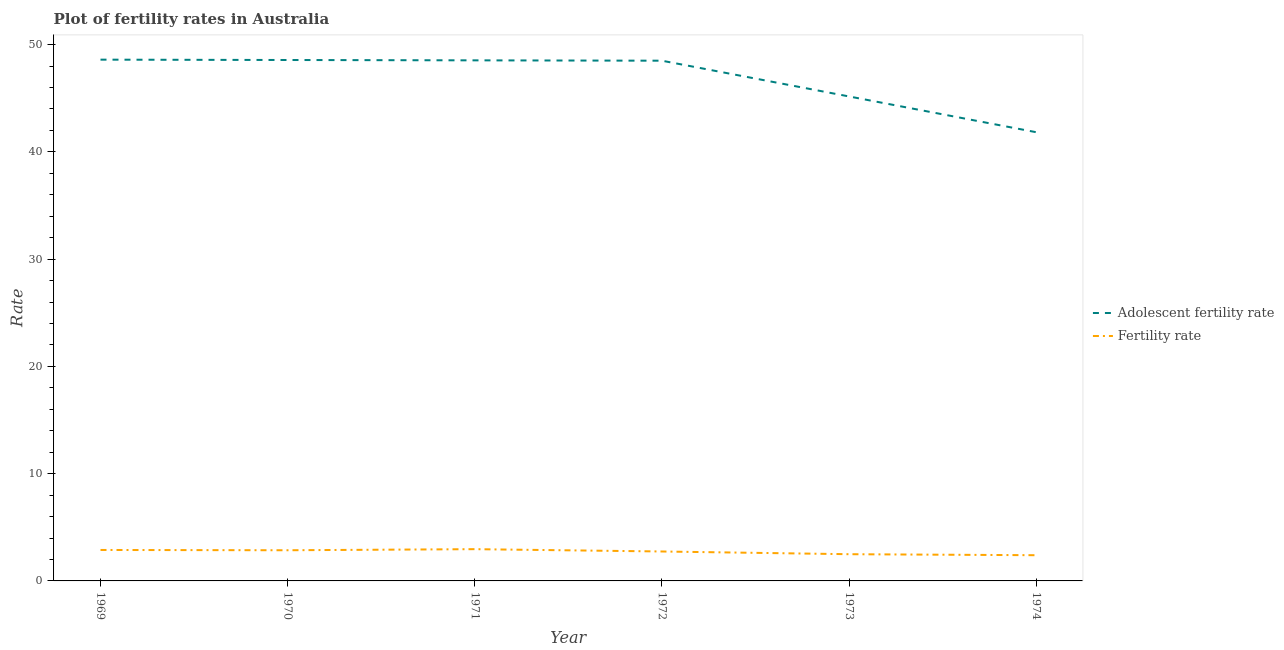How many different coloured lines are there?
Make the answer very short. 2. Does the line corresponding to adolescent fertility rate intersect with the line corresponding to fertility rate?
Provide a succinct answer. No. Is the number of lines equal to the number of legend labels?
Your answer should be very brief. Yes. What is the fertility rate in 1971?
Your answer should be very brief. 2.96. Across all years, what is the maximum adolescent fertility rate?
Your answer should be compact. 48.6. Across all years, what is the minimum adolescent fertility rate?
Your answer should be very brief. 41.83. In which year was the adolescent fertility rate maximum?
Ensure brevity in your answer.  1969. In which year was the adolescent fertility rate minimum?
Your answer should be very brief. 1974. What is the total adolescent fertility rate in the graph?
Offer a very short reply. 281.2. What is the difference between the adolescent fertility rate in 1970 and that in 1972?
Your response must be concise. 0.06. What is the difference between the fertility rate in 1969 and the adolescent fertility rate in 1973?
Give a very brief answer. -42.28. What is the average fertility rate per year?
Your answer should be compact. 2.72. In the year 1969, what is the difference between the adolescent fertility rate and fertility rate?
Offer a very short reply. 45.71. What is the ratio of the fertility rate in 1969 to that in 1974?
Your answer should be very brief. 1.2. Is the difference between the adolescent fertility rate in 1971 and 1972 greater than the difference between the fertility rate in 1971 and 1972?
Ensure brevity in your answer.  No. What is the difference between the highest and the second highest fertility rate?
Ensure brevity in your answer.  0.07. What is the difference between the highest and the lowest fertility rate?
Offer a terse response. 0.56. Is the fertility rate strictly less than the adolescent fertility rate over the years?
Offer a very short reply. Yes. How many years are there in the graph?
Keep it short and to the point. 6. Does the graph contain any zero values?
Keep it short and to the point. No. Does the graph contain grids?
Give a very brief answer. No. Where does the legend appear in the graph?
Offer a terse response. Center right. What is the title of the graph?
Give a very brief answer. Plot of fertility rates in Australia. What is the label or title of the X-axis?
Provide a succinct answer. Year. What is the label or title of the Y-axis?
Your answer should be very brief. Rate. What is the Rate in Adolescent fertility rate in 1969?
Make the answer very short. 48.6. What is the Rate of Fertility rate in 1969?
Your answer should be compact. 2.89. What is the Rate in Adolescent fertility rate in 1970?
Provide a short and direct response. 48.56. What is the Rate of Fertility rate in 1970?
Provide a succinct answer. 2.86. What is the Rate of Adolescent fertility rate in 1971?
Provide a succinct answer. 48.53. What is the Rate in Fertility rate in 1971?
Provide a succinct answer. 2.96. What is the Rate in Adolescent fertility rate in 1972?
Keep it short and to the point. 48.5. What is the Rate of Fertility rate in 1972?
Give a very brief answer. 2.74. What is the Rate in Adolescent fertility rate in 1973?
Your answer should be very brief. 45.17. What is the Rate in Fertility rate in 1973?
Provide a succinct answer. 2.49. What is the Rate in Adolescent fertility rate in 1974?
Provide a short and direct response. 41.83. What is the Rate of Fertility rate in 1974?
Ensure brevity in your answer.  2.4. Across all years, what is the maximum Rate in Adolescent fertility rate?
Ensure brevity in your answer.  48.6. Across all years, what is the maximum Rate of Fertility rate?
Your answer should be compact. 2.96. Across all years, what is the minimum Rate of Adolescent fertility rate?
Make the answer very short. 41.83. Across all years, what is the minimum Rate in Fertility rate?
Give a very brief answer. 2.4. What is the total Rate in Adolescent fertility rate in the graph?
Provide a succinct answer. 281.2. What is the total Rate of Fertility rate in the graph?
Offer a very short reply. 16.34. What is the difference between the Rate in Adolescent fertility rate in 1969 and that in 1970?
Offer a very short reply. 0.03. What is the difference between the Rate in Fertility rate in 1969 and that in 1970?
Offer a terse response. 0.03. What is the difference between the Rate in Adolescent fertility rate in 1969 and that in 1971?
Your answer should be very brief. 0.06. What is the difference between the Rate in Fertility rate in 1969 and that in 1971?
Provide a short and direct response. -0.07. What is the difference between the Rate in Adolescent fertility rate in 1969 and that in 1972?
Your response must be concise. 0.1. What is the difference between the Rate in Fertility rate in 1969 and that in 1972?
Offer a terse response. 0.14. What is the difference between the Rate of Adolescent fertility rate in 1969 and that in 1973?
Ensure brevity in your answer.  3.43. What is the difference between the Rate in Fertility rate in 1969 and that in 1973?
Your answer should be very brief. 0.4. What is the difference between the Rate of Adolescent fertility rate in 1969 and that in 1974?
Your answer should be compact. 6.76. What is the difference between the Rate of Fertility rate in 1969 and that in 1974?
Provide a short and direct response. 0.49. What is the difference between the Rate of Adolescent fertility rate in 1970 and that in 1971?
Offer a very short reply. 0.03. What is the difference between the Rate in Fertility rate in 1970 and that in 1971?
Offer a terse response. -0.1. What is the difference between the Rate in Adolescent fertility rate in 1970 and that in 1972?
Your response must be concise. 0.06. What is the difference between the Rate of Fertility rate in 1970 and that in 1972?
Keep it short and to the point. 0.12. What is the difference between the Rate in Adolescent fertility rate in 1970 and that in 1973?
Keep it short and to the point. 3.4. What is the difference between the Rate in Fertility rate in 1970 and that in 1973?
Your answer should be very brief. 0.37. What is the difference between the Rate of Adolescent fertility rate in 1970 and that in 1974?
Offer a very short reply. 6.73. What is the difference between the Rate of Fertility rate in 1970 and that in 1974?
Make the answer very short. 0.46. What is the difference between the Rate in Adolescent fertility rate in 1971 and that in 1972?
Give a very brief answer. 0.03. What is the difference between the Rate in Fertility rate in 1971 and that in 1972?
Give a very brief answer. 0.22. What is the difference between the Rate of Adolescent fertility rate in 1971 and that in 1973?
Your response must be concise. 3.37. What is the difference between the Rate in Fertility rate in 1971 and that in 1973?
Ensure brevity in your answer.  0.47. What is the difference between the Rate of Adolescent fertility rate in 1971 and that in 1974?
Ensure brevity in your answer.  6.7. What is the difference between the Rate of Fertility rate in 1971 and that in 1974?
Provide a succinct answer. 0.56. What is the difference between the Rate of Adolescent fertility rate in 1972 and that in 1973?
Give a very brief answer. 3.33. What is the difference between the Rate in Fertility rate in 1972 and that in 1973?
Your answer should be compact. 0.25. What is the difference between the Rate in Adolescent fertility rate in 1972 and that in 1974?
Provide a short and direct response. 6.67. What is the difference between the Rate of Fertility rate in 1972 and that in 1974?
Offer a very short reply. 0.35. What is the difference between the Rate in Adolescent fertility rate in 1973 and that in 1974?
Make the answer very short. 3.33. What is the difference between the Rate of Fertility rate in 1973 and that in 1974?
Provide a short and direct response. 0.09. What is the difference between the Rate of Adolescent fertility rate in 1969 and the Rate of Fertility rate in 1970?
Your answer should be compact. 45.74. What is the difference between the Rate in Adolescent fertility rate in 1969 and the Rate in Fertility rate in 1971?
Give a very brief answer. 45.64. What is the difference between the Rate in Adolescent fertility rate in 1969 and the Rate in Fertility rate in 1972?
Your answer should be compact. 45.85. What is the difference between the Rate of Adolescent fertility rate in 1969 and the Rate of Fertility rate in 1973?
Make the answer very short. 46.11. What is the difference between the Rate in Adolescent fertility rate in 1969 and the Rate in Fertility rate in 1974?
Your answer should be compact. 46.2. What is the difference between the Rate in Adolescent fertility rate in 1970 and the Rate in Fertility rate in 1971?
Your answer should be compact. 45.6. What is the difference between the Rate in Adolescent fertility rate in 1970 and the Rate in Fertility rate in 1972?
Give a very brief answer. 45.82. What is the difference between the Rate in Adolescent fertility rate in 1970 and the Rate in Fertility rate in 1973?
Ensure brevity in your answer.  46.07. What is the difference between the Rate in Adolescent fertility rate in 1970 and the Rate in Fertility rate in 1974?
Make the answer very short. 46.17. What is the difference between the Rate of Adolescent fertility rate in 1971 and the Rate of Fertility rate in 1972?
Your answer should be very brief. 45.79. What is the difference between the Rate of Adolescent fertility rate in 1971 and the Rate of Fertility rate in 1973?
Offer a very short reply. 46.04. What is the difference between the Rate in Adolescent fertility rate in 1971 and the Rate in Fertility rate in 1974?
Your answer should be very brief. 46.14. What is the difference between the Rate of Adolescent fertility rate in 1972 and the Rate of Fertility rate in 1973?
Keep it short and to the point. 46.01. What is the difference between the Rate in Adolescent fertility rate in 1972 and the Rate in Fertility rate in 1974?
Your answer should be compact. 46.1. What is the difference between the Rate of Adolescent fertility rate in 1973 and the Rate of Fertility rate in 1974?
Make the answer very short. 42.77. What is the average Rate in Adolescent fertility rate per year?
Offer a very short reply. 46.87. What is the average Rate in Fertility rate per year?
Give a very brief answer. 2.72. In the year 1969, what is the difference between the Rate in Adolescent fertility rate and Rate in Fertility rate?
Make the answer very short. 45.71. In the year 1970, what is the difference between the Rate of Adolescent fertility rate and Rate of Fertility rate?
Provide a short and direct response. 45.71. In the year 1971, what is the difference between the Rate in Adolescent fertility rate and Rate in Fertility rate?
Provide a succinct answer. 45.57. In the year 1972, what is the difference between the Rate of Adolescent fertility rate and Rate of Fertility rate?
Offer a very short reply. 45.76. In the year 1973, what is the difference between the Rate in Adolescent fertility rate and Rate in Fertility rate?
Make the answer very short. 42.68. In the year 1974, what is the difference between the Rate of Adolescent fertility rate and Rate of Fertility rate?
Keep it short and to the point. 39.44. What is the ratio of the Rate of Fertility rate in 1969 to that in 1970?
Your response must be concise. 1.01. What is the ratio of the Rate of Fertility rate in 1969 to that in 1971?
Keep it short and to the point. 0.97. What is the ratio of the Rate in Adolescent fertility rate in 1969 to that in 1972?
Provide a succinct answer. 1. What is the ratio of the Rate of Fertility rate in 1969 to that in 1972?
Your answer should be very brief. 1.05. What is the ratio of the Rate of Adolescent fertility rate in 1969 to that in 1973?
Your answer should be very brief. 1.08. What is the ratio of the Rate in Fertility rate in 1969 to that in 1973?
Your answer should be very brief. 1.16. What is the ratio of the Rate in Adolescent fertility rate in 1969 to that in 1974?
Your response must be concise. 1.16. What is the ratio of the Rate in Fertility rate in 1969 to that in 1974?
Offer a very short reply. 1.2. What is the ratio of the Rate of Adolescent fertility rate in 1970 to that in 1971?
Provide a succinct answer. 1. What is the ratio of the Rate of Fertility rate in 1970 to that in 1971?
Provide a short and direct response. 0.97. What is the ratio of the Rate in Fertility rate in 1970 to that in 1972?
Ensure brevity in your answer.  1.04. What is the ratio of the Rate of Adolescent fertility rate in 1970 to that in 1973?
Your answer should be very brief. 1.08. What is the ratio of the Rate of Fertility rate in 1970 to that in 1973?
Your answer should be very brief. 1.15. What is the ratio of the Rate in Adolescent fertility rate in 1970 to that in 1974?
Provide a short and direct response. 1.16. What is the ratio of the Rate of Fertility rate in 1970 to that in 1974?
Your answer should be very brief. 1.19. What is the ratio of the Rate in Adolescent fertility rate in 1971 to that in 1972?
Give a very brief answer. 1. What is the ratio of the Rate of Fertility rate in 1971 to that in 1972?
Provide a succinct answer. 1.08. What is the ratio of the Rate of Adolescent fertility rate in 1971 to that in 1973?
Offer a terse response. 1.07. What is the ratio of the Rate of Fertility rate in 1971 to that in 1973?
Offer a terse response. 1.19. What is the ratio of the Rate in Adolescent fertility rate in 1971 to that in 1974?
Give a very brief answer. 1.16. What is the ratio of the Rate of Fertility rate in 1971 to that in 1974?
Provide a short and direct response. 1.24. What is the ratio of the Rate in Adolescent fertility rate in 1972 to that in 1973?
Keep it short and to the point. 1.07. What is the ratio of the Rate in Fertility rate in 1972 to that in 1973?
Offer a terse response. 1.1. What is the ratio of the Rate of Adolescent fertility rate in 1972 to that in 1974?
Keep it short and to the point. 1.16. What is the ratio of the Rate of Fertility rate in 1972 to that in 1974?
Keep it short and to the point. 1.14. What is the ratio of the Rate in Adolescent fertility rate in 1973 to that in 1974?
Your answer should be very brief. 1.08. What is the ratio of the Rate in Fertility rate in 1973 to that in 1974?
Provide a short and direct response. 1.04. What is the difference between the highest and the second highest Rate of Adolescent fertility rate?
Offer a terse response. 0.03. What is the difference between the highest and the second highest Rate in Fertility rate?
Offer a terse response. 0.07. What is the difference between the highest and the lowest Rate of Adolescent fertility rate?
Your answer should be compact. 6.76. What is the difference between the highest and the lowest Rate in Fertility rate?
Provide a short and direct response. 0.56. 